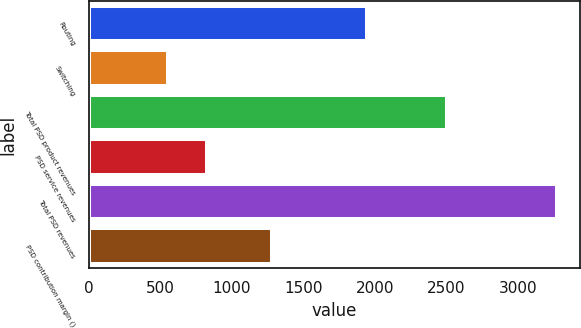Convert chart to OTSL. <chart><loc_0><loc_0><loc_500><loc_500><bar_chart><fcel>Routing<fcel>Switching<fcel>Total PSD product revenues<fcel>PSD service revenues<fcel>Total PSD revenues<fcel>PSD contribution margin ()<nl><fcel>1946.8<fcel>554.8<fcel>2501.6<fcel>826.4<fcel>3270.8<fcel>1276.4<nl></chart> 